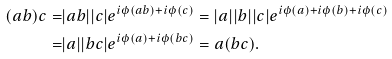<formula> <loc_0><loc_0><loc_500><loc_500>( a b ) c = & | a b | | c | e ^ { i \phi ( a b ) + i \phi ( c ) } = | a | | b | | c | e ^ { i \phi ( a ) + i \phi ( b ) + i \phi ( c ) } \\ = & | a | | b c | e ^ { i \phi ( a ) + i \phi ( b c ) } = a ( b c ) .</formula> 